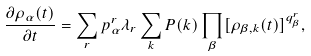<formula> <loc_0><loc_0><loc_500><loc_500>\frac { \partial \rho _ { \alpha } ( t ) } { \partial t } = \sum _ { r } p _ { \alpha } ^ { r } \lambda _ { r } \sum _ { k } P ( k ) \prod _ { \beta } [ \rho _ { \beta , k } ( t ) ] ^ { q _ { \beta } ^ { r } } ,</formula> 